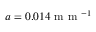<formula> <loc_0><loc_0><loc_500><loc_500>a = 0 . 0 1 4 m m ^ { - 1 }</formula> 